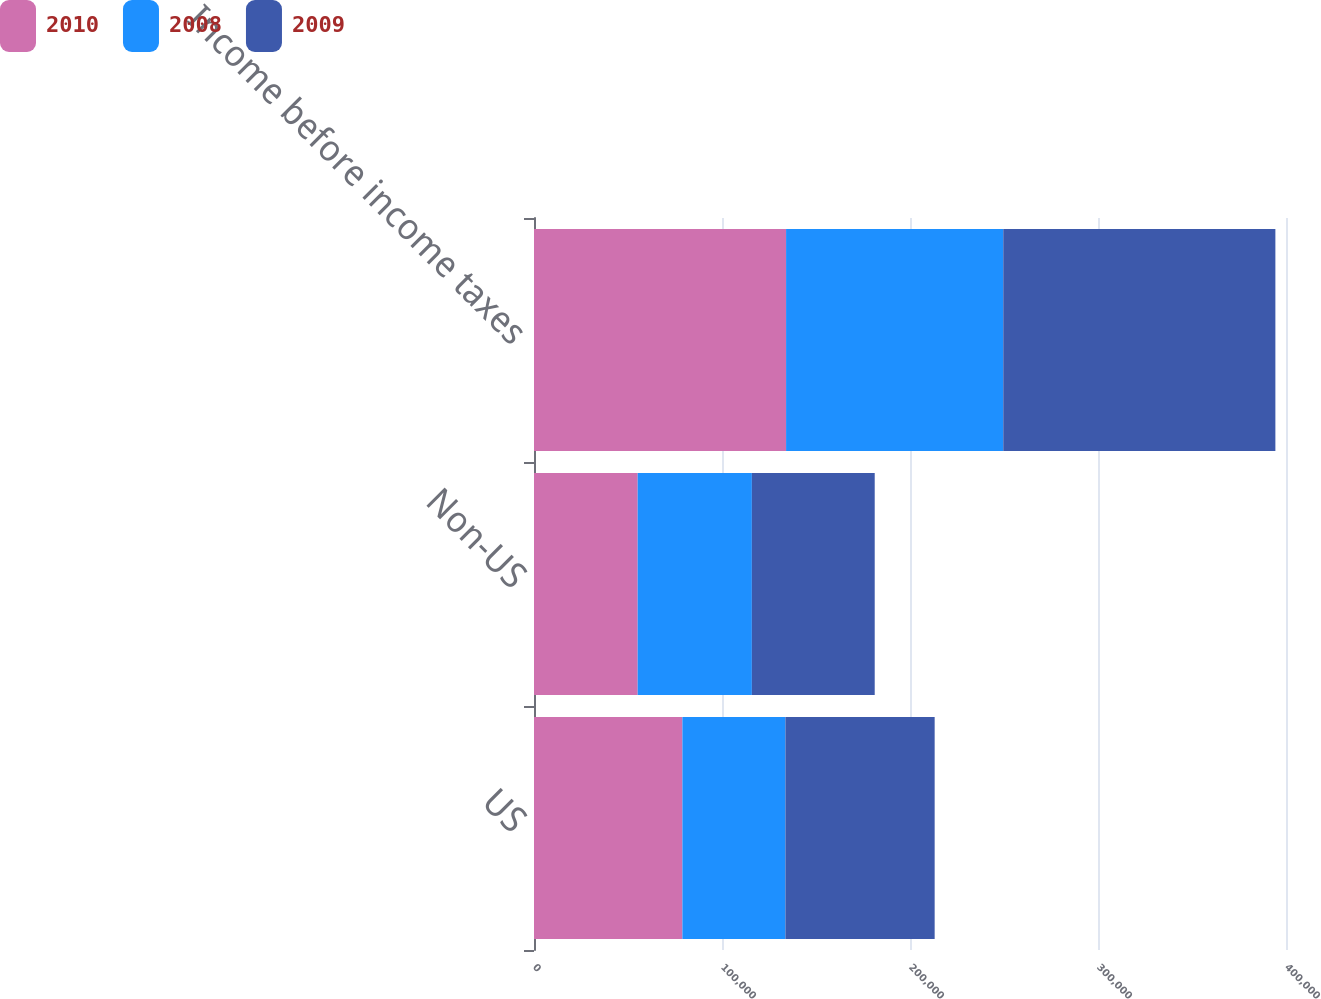Convert chart to OTSL. <chart><loc_0><loc_0><loc_500><loc_500><stacked_bar_chart><ecel><fcel>US<fcel>Non-US<fcel>Income before income taxes<nl><fcel>2010<fcel>78933<fcel>55152<fcel>134085<nl><fcel>2008<fcel>54793<fcel>60733<fcel>115526<nl><fcel>2009<fcel>79393<fcel>65348<fcel>144741<nl></chart> 